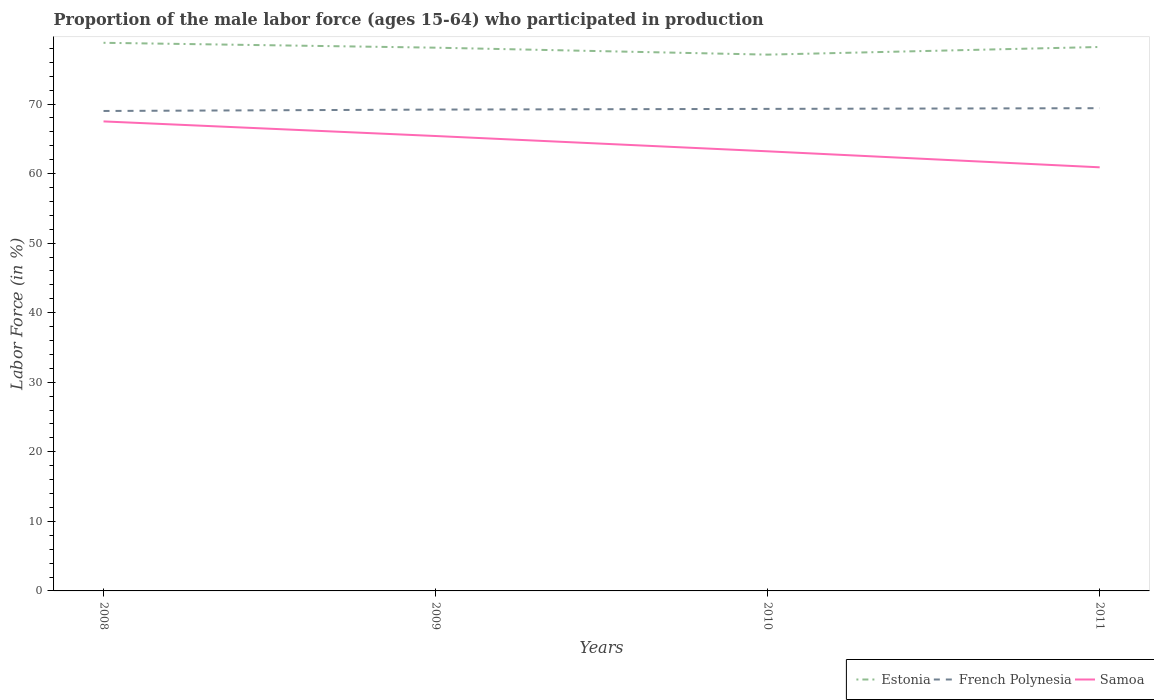How many different coloured lines are there?
Your answer should be very brief. 3. Is the number of lines equal to the number of legend labels?
Offer a terse response. Yes. Across all years, what is the maximum proportion of the male labor force who participated in production in Samoa?
Make the answer very short. 60.9. What is the total proportion of the male labor force who participated in production in French Polynesia in the graph?
Offer a terse response. -0.2. What is the difference between the highest and the second highest proportion of the male labor force who participated in production in Samoa?
Make the answer very short. 6.6. What is the difference between the highest and the lowest proportion of the male labor force who participated in production in French Polynesia?
Ensure brevity in your answer.  2. Is the proportion of the male labor force who participated in production in French Polynesia strictly greater than the proportion of the male labor force who participated in production in Estonia over the years?
Provide a succinct answer. Yes. How many years are there in the graph?
Your response must be concise. 4. Are the values on the major ticks of Y-axis written in scientific E-notation?
Your answer should be compact. No. What is the title of the graph?
Give a very brief answer. Proportion of the male labor force (ages 15-64) who participated in production. Does "Korea (Democratic)" appear as one of the legend labels in the graph?
Ensure brevity in your answer.  No. What is the label or title of the X-axis?
Make the answer very short. Years. What is the Labor Force (in %) in Estonia in 2008?
Give a very brief answer. 78.8. What is the Labor Force (in %) of Samoa in 2008?
Provide a short and direct response. 67.5. What is the Labor Force (in %) of Estonia in 2009?
Keep it short and to the point. 78.1. What is the Labor Force (in %) of French Polynesia in 2009?
Offer a terse response. 69.2. What is the Labor Force (in %) of Samoa in 2009?
Your answer should be very brief. 65.4. What is the Labor Force (in %) in Estonia in 2010?
Ensure brevity in your answer.  77.1. What is the Labor Force (in %) of French Polynesia in 2010?
Your answer should be very brief. 69.3. What is the Labor Force (in %) of Samoa in 2010?
Offer a very short reply. 63.2. What is the Labor Force (in %) of Estonia in 2011?
Make the answer very short. 78.2. What is the Labor Force (in %) of French Polynesia in 2011?
Your answer should be compact. 69.4. What is the Labor Force (in %) in Samoa in 2011?
Make the answer very short. 60.9. Across all years, what is the maximum Labor Force (in %) in Estonia?
Your answer should be very brief. 78.8. Across all years, what is the maximum Labor Force (in %) in French Polynesia?
Keep it short and to the point. 69.4. Across all years, what is the maximum Labor Force (in %) of Samoa?
Your answer should be compact. 67.5. Across all years, what is the minimum Labor Force (in %) in Estonia?
Provide a short and direct response. 77.1. Across all years, what is the minimum Labor Force (in %) of Samoa?
Offer a very short reply. 60.9. What is the total Labor Force (in %) of Estonia in the graph?
Your answer should be very brief. 312.2. What is the total Labor Force (in %) of French Polynesia in the graph?
Offer a terse response. 276.9. What is the total Labor Force (in %) in Samoa in the graph?
Provide a short and direct response. 257. What is the difference between the Labor Force (in %) in Estonia in 2008 and that in 2010?
Offer a terse response. 1.7. What is the difference between the Labor Force (in %) of Samoa in 2008 and that in 2010?
Provide a short and direct response. 4.3. What is the difference between the Labor Force (in %) of French Polynesia in 2008 and that in 2011?
Keep it short and to the point. -0.4. What is the difference between the Labor Force (in %) of Samoa in 2008 and that in 2011?
Provide a short and direct response. 6.6. What is the difference between the Labor Force (in %) in Estonia in 2009 and that in 2010?
Your response must be concise. 1. What is the difference between the Labor Force (in %) of French Polynesia in 2009 and that in 2010?
Your answer should be compact. -0.1. What is the difference between the Labor Force (in %) in Samoa in 2009 and that in 2010?
Offer a very short reply. 2.2. What is the difference between the Labor Force (in %) in Estonia in 2009 and that in 2011?
Offer a very short reply. -0.1. What is the difference between the Labor Force (in %) in French Polynesia in 2009 and that in 2011?
Ensure brevity in your answer.  -0.2. What is the difference between the Labor Force (in %) of Samoa in 2009 and that in 2011?
Offer a terse response. 4.5. What is the difference between the Labor Force (in %) of Estonia in 2010 and that in 2011?
Give a very brief answer. -1.1. What is the difference between the Labor Force (in %) of Estonia in 2008 and the Labor Force (in %) of French Polynesia in 2009?
Your response must be concise. 9.6. What is the difference between the Labor Force (in %) of Estonia in 2008 and the Labor Force (in %) of French Polynesia in 2010?
Provide a short and direct response. 9.5. What is the difference between the Labor Force (in %) in French Polynesia in 2008 and the Labor Force (in %) in Samoa in 2010?
Your answer should be very brief. 5.8. What is the difference between the Labor Force (in %) in Estonia in 2008 and the Labor Force (in %) in Samoa in 2011?
Provide a short and direct response. 17.9. What is the difference between the Labor Force (in %) of French Polynesia in 2008 and the Labor Force (in %) of Samoa in 2011?
Provide a succinct answer. 8.1. What is the difference between the Labor Force (in %) in French Polynesia in 2009 and the Labor Force (in %) in Samoa in 2010?
Offer a terse response. 6. What is the difference between the Labor Force (in %) in French Polynesia in 2009 and the Labor Force (in %) in Samoa in 2011?
Make the answer very short. 8.3. What is the difference between the Labor Force (in %) of Estonia in 2010 and the Labor Force (in %) of French Polynesia in 2011?
Offer a terse response. 7.7. What is the difference between the Labor Force (in %) of Estonia in 2010 and the Labor Force (in %) of Samoa in 2011?
Offer a very short reply. 16.2. What is the average Labor Force (in %) of Estonia per year?
Ensure brevity in your answer.  78.05. What is the average Labor Force (in %) of French Polynesia per year?
Ensure brevity in your answer.  69.22. What is the average Labor Force (in %) in Samoa per year?
Offer a terse response. 64.25. In the year 2008, what is the difference between the Labor Force (in %) of Estonia and Labor Force (in %) of French Polynesia?
Offer a terse response. 9.8. In the year 2008, what is the difference between the Labor Force (in %) in Estonia and Labor Force (in %) in Samoa?
Give a very brief answer. 11.3. In the year 2009, what is the difference between the Labor Force (in %) of Estonia and Labor Force (in %) of Samoa?
Provide a short and direct response. 12.7. In the year 2010, what is the difference between the Labor Force (in %) of Estonia and Labor Force (in %) of French Polynesia?
Provide a succinct answer. 7.8. In the year 2011, what is the difference between the Labor Force (in %) in Estonia and Labor Force (in %) in French Polynesia?
Your answer should be compact. 8.8. In the year 2011, what is the difference between the Labor Force (in %) of Estonia and Labor Force (in %) of Samoa?
Provide a short and direct response. 17.3. In the year 2011, what is the difference between the Labor Force (in %) in French Polynesia and Labor Force (in %) in Samoa?
Offer a terse response. 8.5. What is the ratio of the Labor Force (in %) of French Polynesia in 2008 to that in 2009?
Provide a succinct answer. 1. What is the ratio of the Labor Force (in %) in Samoa in 2008 to that in 2009?
Make the answer very short. 1.03. What is the ratio of the Labor Force (in %) in Estonia in 2008 to that in 2010?
Your answer should be compact. 1.02. What is the ratio of the Labor Force (in %) in French Polynesia in 2008 to that in 2010?
Your answer should be compact. 1. What is the ratio of the Labor Force (in %) of Samoa in 2008 to that in 2010?
Your answer should be compact. 1.07. What is the ratio of the Labor Force (in %) of Estonia in 2008 to that in 2011?
Make the answer very short. 1.01. What is the ratio of the Labor Force (in %) in French Polynesia in 2008 to that in 2011?
Your answer should be very brief. 0.99. What is the ratio of the Labor Force (in %) in Samoa in 2008 to that in 2011?
Make the answer very short. 1.11. What is the ratio of the Labor Force (in %) of Estonia in 2009 to that in 2010?
Your answer should be very brief. 1.01. What is the ratio of the Labor Force (in %) of Samoa in 2009 to that in 2010?
Your answer should be very brief. 1.03. What is the ratio of the Labor Force (in %) in French Polynesia in 2009 to that in 2011?
Provide a short and direct response. 1. What is the ratio of the Labor Force (in %) of Samoa in 2009 to that in 2011?
Your response must be concise. 1.07. What is the ratio of the Labor Force (in %) in Estonia in 2010 to that in 2011?
Provide a succinct answer. 0.99. What is the ratio of the Labor Force (in %) of Samoa in 2010 to that in 2011?
Your response must be concise. 1.04. What is the difference between the highest and the second highest Labor Force (in %) in Estonia?
Ensure brevity in your answer.  0.6. What is the difference between the highest and the second highest Labor Force (in %) in French Polynesia?
Offer a very short reply. 0.1. What is the difference between the highest and the second highest Labor Force (in %) of Samoa?
Your answer should be very brief. 2.1. What is the difference between the highest and the lowest Labor Force (in %) in French Polynesia?
Your answer should be very brief. 0.4. What is the difference between the highest and the lowest Labor Force (in %) of Samoa?
Make the answer very short. 6.6. 